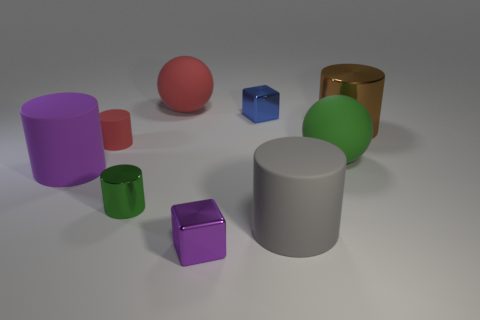Add 1 green metallic cylinders. How many objects exist? 10 Subtract all big gray cylinders. How many cylinders are left? 4 Subtract all purple cylinders. How many cylinders are left? 4 Subtract 0 cyan blocks. How many objects are left? 9 Subtract all blocks. How many objects are left? 7 Subtract 2 cubes. How many cubes are left? 0 Subtract all green cubes. Subtract all brown cylinders. How many cubes are left? 2 Subtract all green cylinders. How many purple cubes are left? 1 Subtract all brown cylinders. Subtract all big red matte spheres. How many objects are left? 7 Add 4 big green objects. How many big green objects are left? 5 